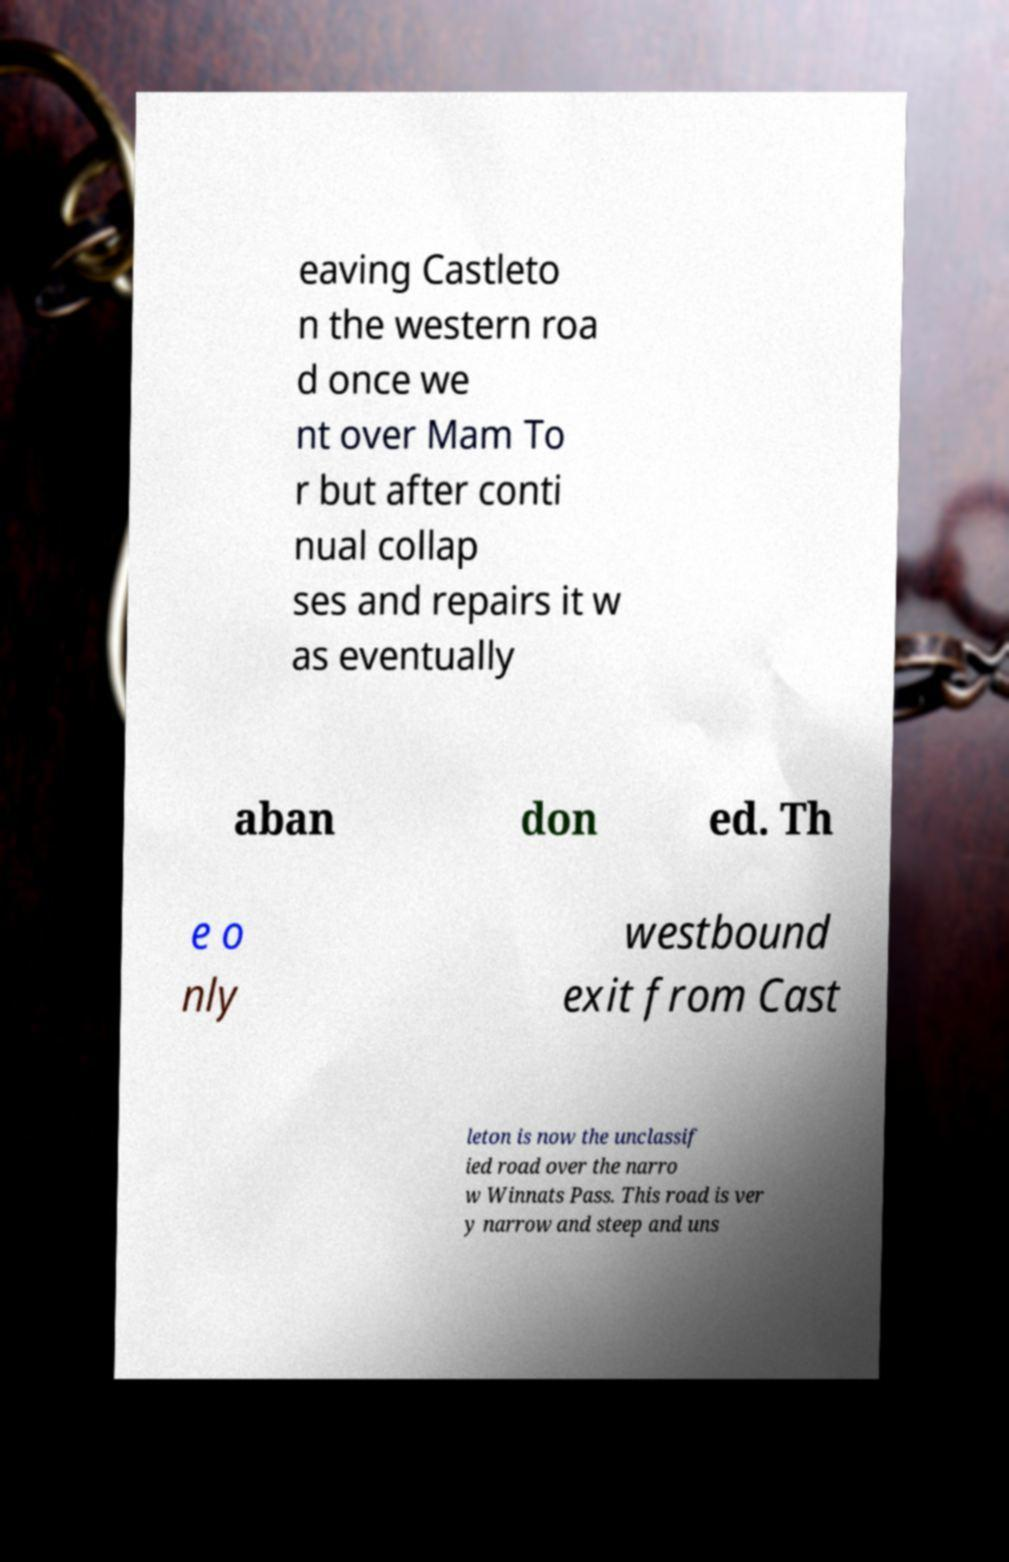Could you extract and type out the text from this image? eaving Castleto n the western roa d once we nt over Mam To r but after conti nual collap ses and repairs it w as eventually aban don ed. Th e o nly westbound exit from Cast leton is now the unclassif ied road over the narro w Winnats Pass. This road is ver y narrow and steep and uns 